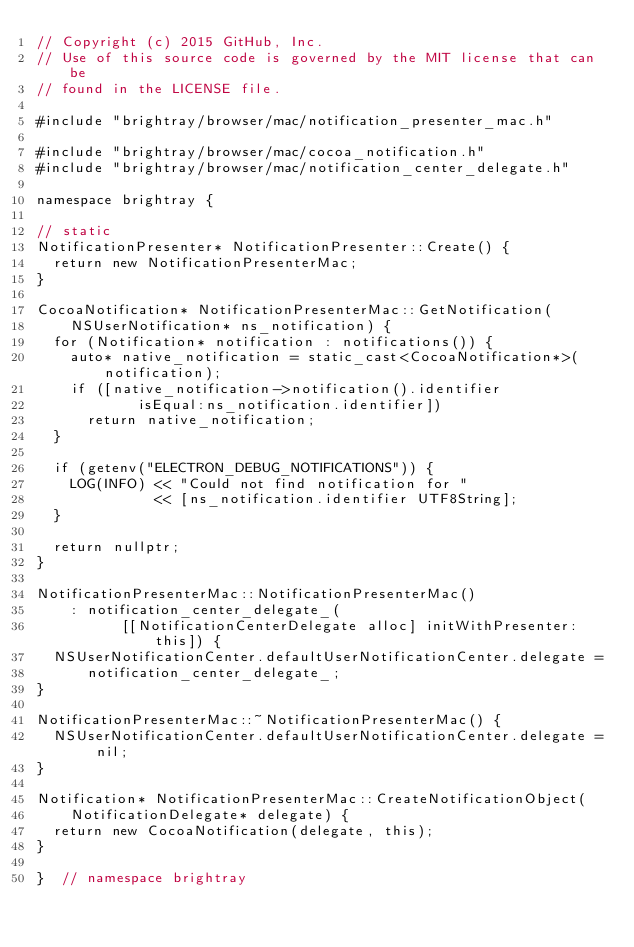Convert code to text. <code><loc_0><loc_0><loc_500><loc_500><_ObjectiveC_>// Copyright (c) 2015 GitHub, Inc.
// Use of this source code is governed by the MIT license that can be
// found in the LICENSE file.

#include "brightray/browser/mac/notification_presenter_mac.h"

#include "brightray/browser/mac/cocoa_notification.h"
#include "brightray/browser/mac/notification_center_delegate.h"

namespace brightray {

// static
NotificationPresenter* NotificationPresenter::Create() {
  return new NotificationPresenterMac;
}

CocoaNotification* NotificationPresenterMac::GetNotification(
    NSUserNotification* ns_notification) {
  for (Notification* notification : notifications()) {
    auto* native_notification = static_cast<CocoaNotification*>(notification);
    if ([native_notification->notification().identifier
            isEqual:ns_notification.identifier])
      return native_notification;
  }

  if (getenv("ELECTRON_DEBUG_NOTIFICATIONS")) {
    LOG(INFO) << "Could not find notification for "
              << [ns_notification.identifier UTF8String];
  }

  return nullptr;
}

NotificationPresenterMac::NotificationPresenterMac()
    : notification_center_delegate_(
          [[NotificationCenterDelegate alloc] initWithPresenter:this]) {
  NSUserNotificationCenter.defaultUserNotificationCenter.delegate =
      notification_center_delegate_;
}

NotificationPresenterMac::~NotificationPresenterMac() {
  NSUserNotificationCenter.defaultUserNotificationCenter.delegate = nil;
}

Notification* NotificationPresenterMac::CreateNotificationObject(
    NotificationDelegate* delegate) {
  return new CocoaNotification(delegate, this);
}

}  // namespace brightray
</code> 